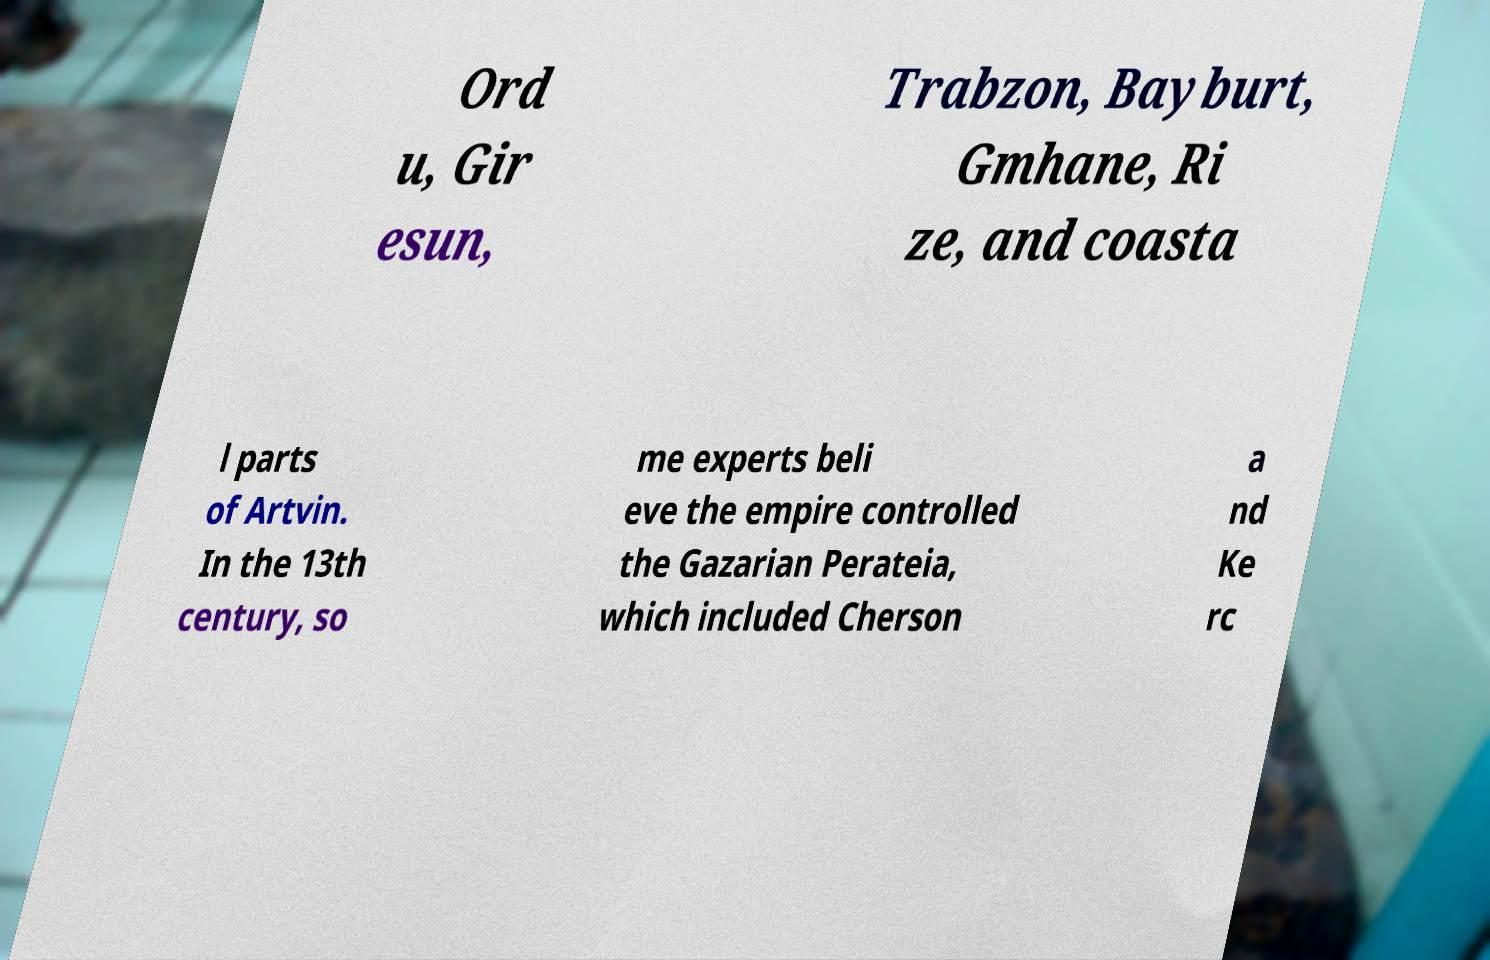For documentation purposes, I need the text within this image transcribed. Could you provide that? Ord u, Gir esun, Trabzon, Bayburt, Gmhane, Ri ze, and coasta l parts of Artvin. In the 13th century, so me experts beli eve the empire controlled the Gazarian Perateia, which included Cherson a nd Ke rc 